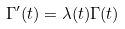<formula> <loc_0><loc_0><loc_500><loc_500>\Gamma ^ { \prime } ( t ) = \lambda ( t ) \Gamma ( t )</formula> 